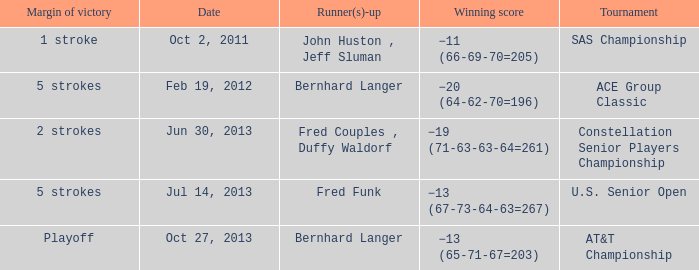Which Date has a Runner(s)-up of bernhard langer, and a Tournament of at&t championship? Oct 27, 2013. 